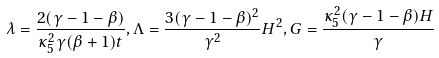Convert formula to latex. <formula><loc_0><loc_0><loc_500><loc_500>\lambda = \frac { 2 ( \gamma - 1 - \beta ) } { \kappa ^ { 2 } _ { 5 } \gamma ( \beta + 1 ) t } , \Lambda = \frac { 3 ( \gamma - 1 - \beta ) ^ { 2 } } { \gamma ^ { 2 } } H ^ { 2 } , G = \frac { \kappa ^ { 2 } _ { 5 } ( \gamma - 1 - \beta ) H } { \gamma }</formula> 